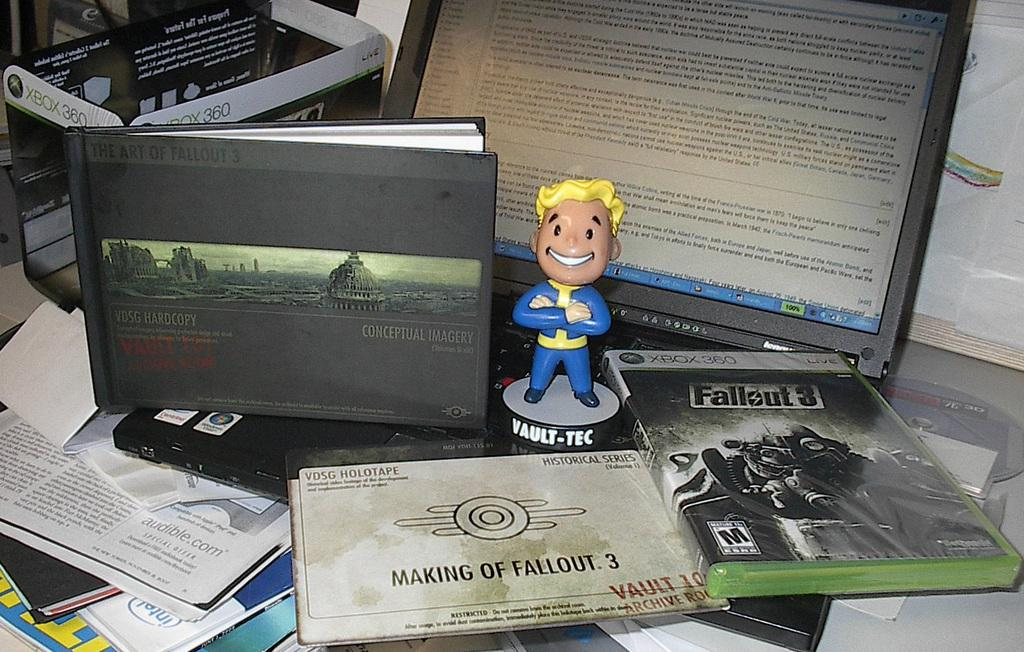<image>
Share a concise interpretation of the image provided. A Fallout 3 Xbox game is in front of a book and figurine. 